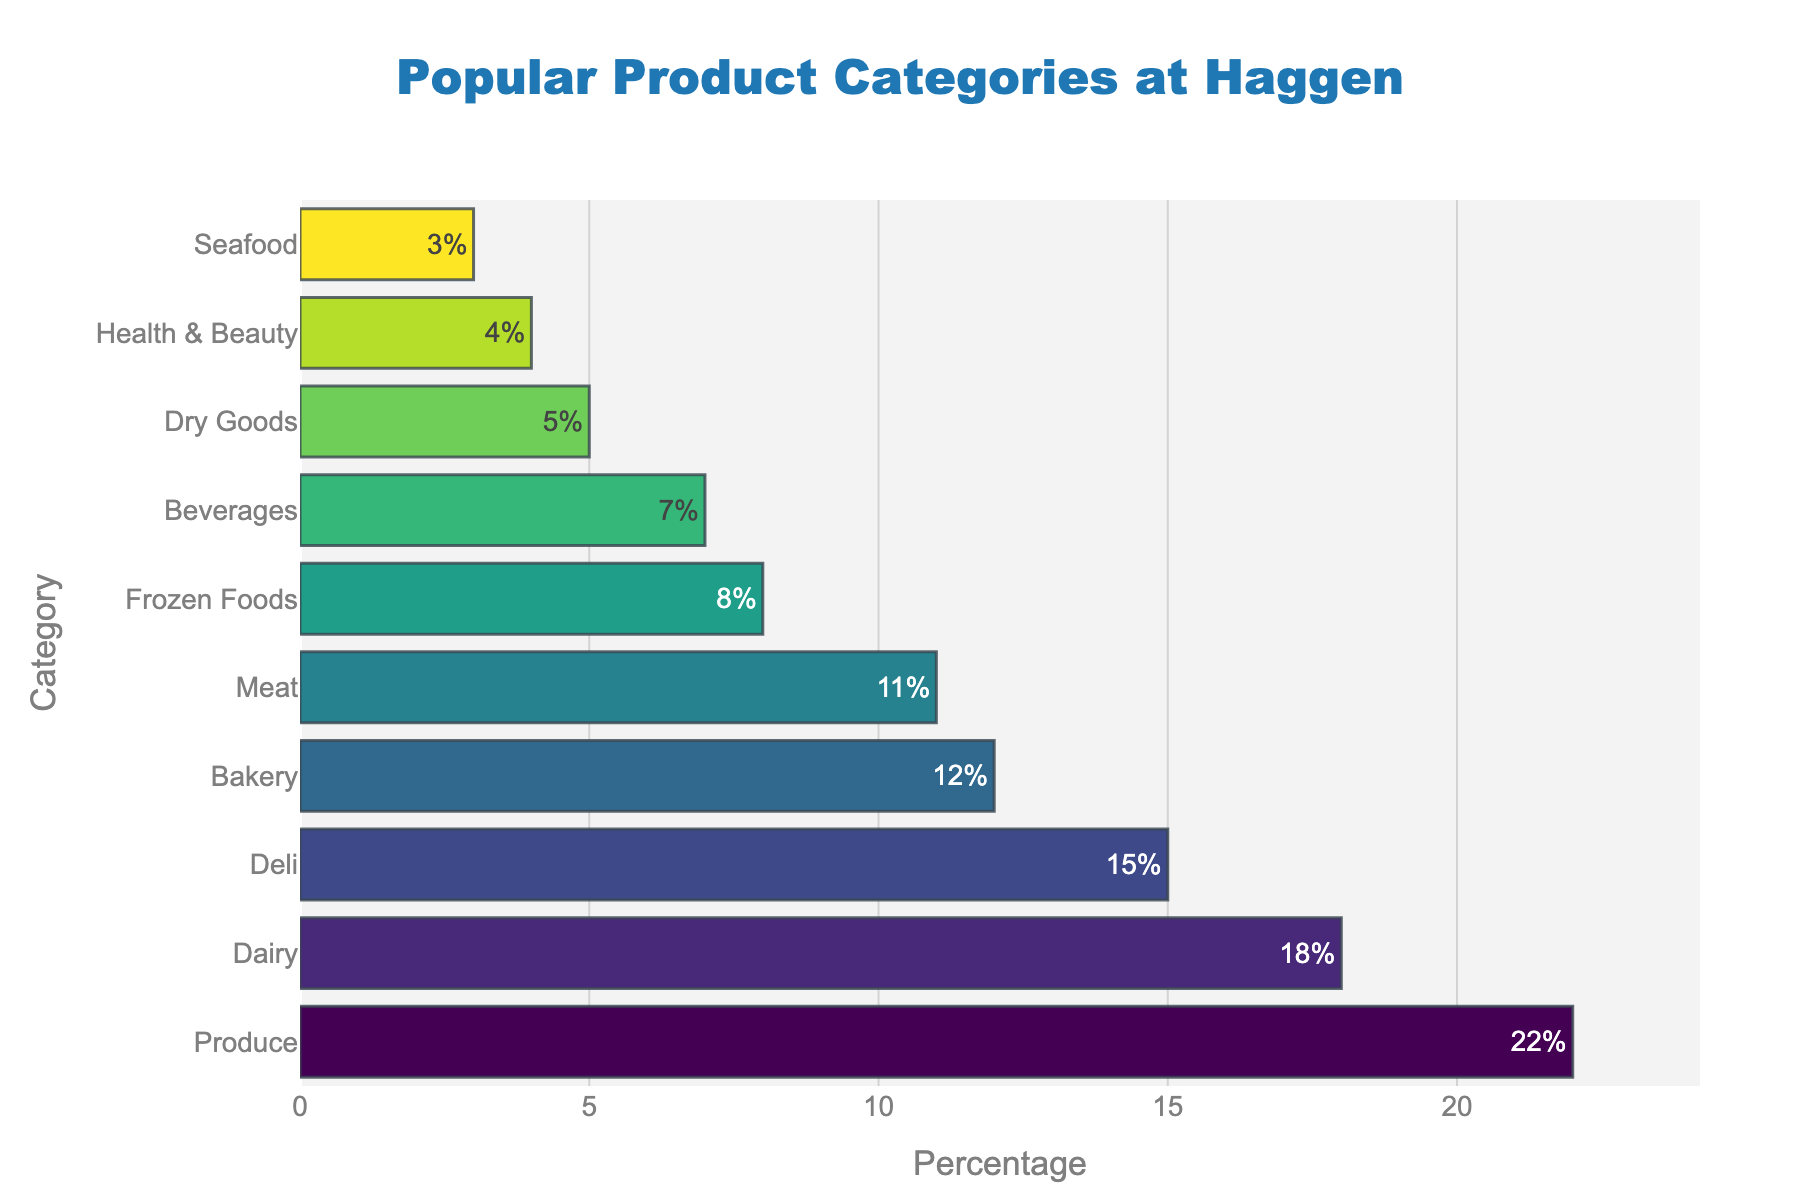What are the top two product categories in terms of percentage? The top two categories based on the bar lengths would be the longest and the second longest bars. The longest bar corresponds to Produce at 22%, and the second longest corresponds to Dairy at 18%.
Answer: Produce and Dairy What is the total percentage of products sold in the Deli, Bakery, and Meat categories? Sum the percentages of Deli (15%), Bakery (12%), and Meat (11%). The total is 15% + 12% + 11% = 38%.
Answer: 38% Which product category has the least percentage, and what is it? The shortest bar on the chart represents the category with the least percentage. This is Seafood, which has a percentage of 3%.
Answer: Seafood at 3% How much higher is the percentage of Produce compared to Frozen Foods? Subtract the percentage of Frozen Foods (8%) from the percentage of Produce (22%). The result is 22% - 8% = 14%.
Answer: 14% What is the average percentage of the Dairy, Deli, and Bakery categories? Sum the percentages of Dairy (18%), Deli (15%), and Bakery (12%), then divide by the number of categories (3). The calculation is (18% + 15% + 12%) / 3 = 45% / 3 = 15%.
Answer: 15% Which category represents the middle value in the ordered list of percentages? Ordering the categories by percentage, the middle value falls in the fifth position. The sorted percentages are: 22%, 18%, 15%, 12%, 11%, 8%, 7%, 5%, 4%, 3%. The middle value or median is 11%, which corresponds to the Meat category.
Answer: Meat In which range do most of the product category percentages fall? (0-5%, 5-10%, 10-15%, 15-20%, and 20-25%) From the sorted data, the categories and their percentages are ordered. We count how many percentages fall into each range: 0-5% (3 categories), 5-10% (2 categories), 10-15% (3 categories), 15-20% (1 category), and 20-25% (1 category). The most common range contains 3 categories: 0-5%, and 10-15%.
Answer: 0-5% and 10-15% Compare the length of the bars for Beverages and Dry Goods. Which one is longer? By visually comparing the lengths of the bars representing Beverages (7%) and Dry Goods (5%), the bar for Beverages is longer.
Answer: Beverages 